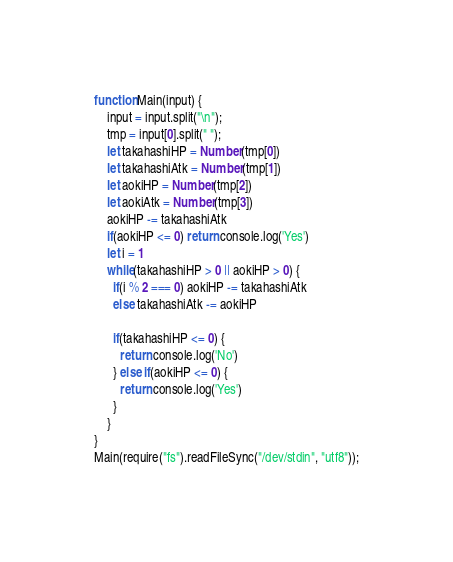<code> <loc_0><loc_0><loc_500><loc_500><_JavaScript_>function Main(input) {
	input = input.split("\n");
	tmp = input[0].split(" ");
    let takahashiHP = Number(tmp[0])
    let takahashiAtk = Number(tmp[1])
    let aokiHP = Number(tmp[2])
    let aokiAtk = Number(tmp[3])
    aokiHP -= takahashiAtk
  	if(aokiHP <= 0) return console.log('Yes')
  	let i = 1
    while(takahashiHP > 0 || aokiHP > 0) {
      if(i % 2 === 0) aokiHP -= takahashiAtk
      else takahashiAtk -= aokiHP
      
      if(takahashiHP <= 0) {
        return console.log('No')
      } else if(aokiHP <= 0) {
        return console.log('Yes')
      }
    }
}
Main(require("fs").readFileSync("/dev/stdin", "utf8"));</code> 